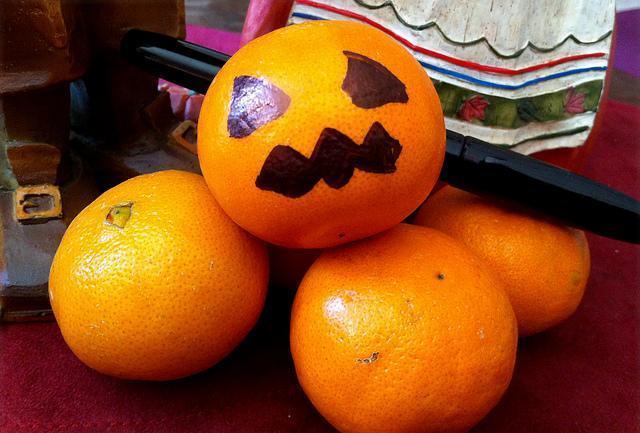How many oranges can you see?
Give a very brief answer. 4. How many oranges are there?
Give a very brief answer. 4. 